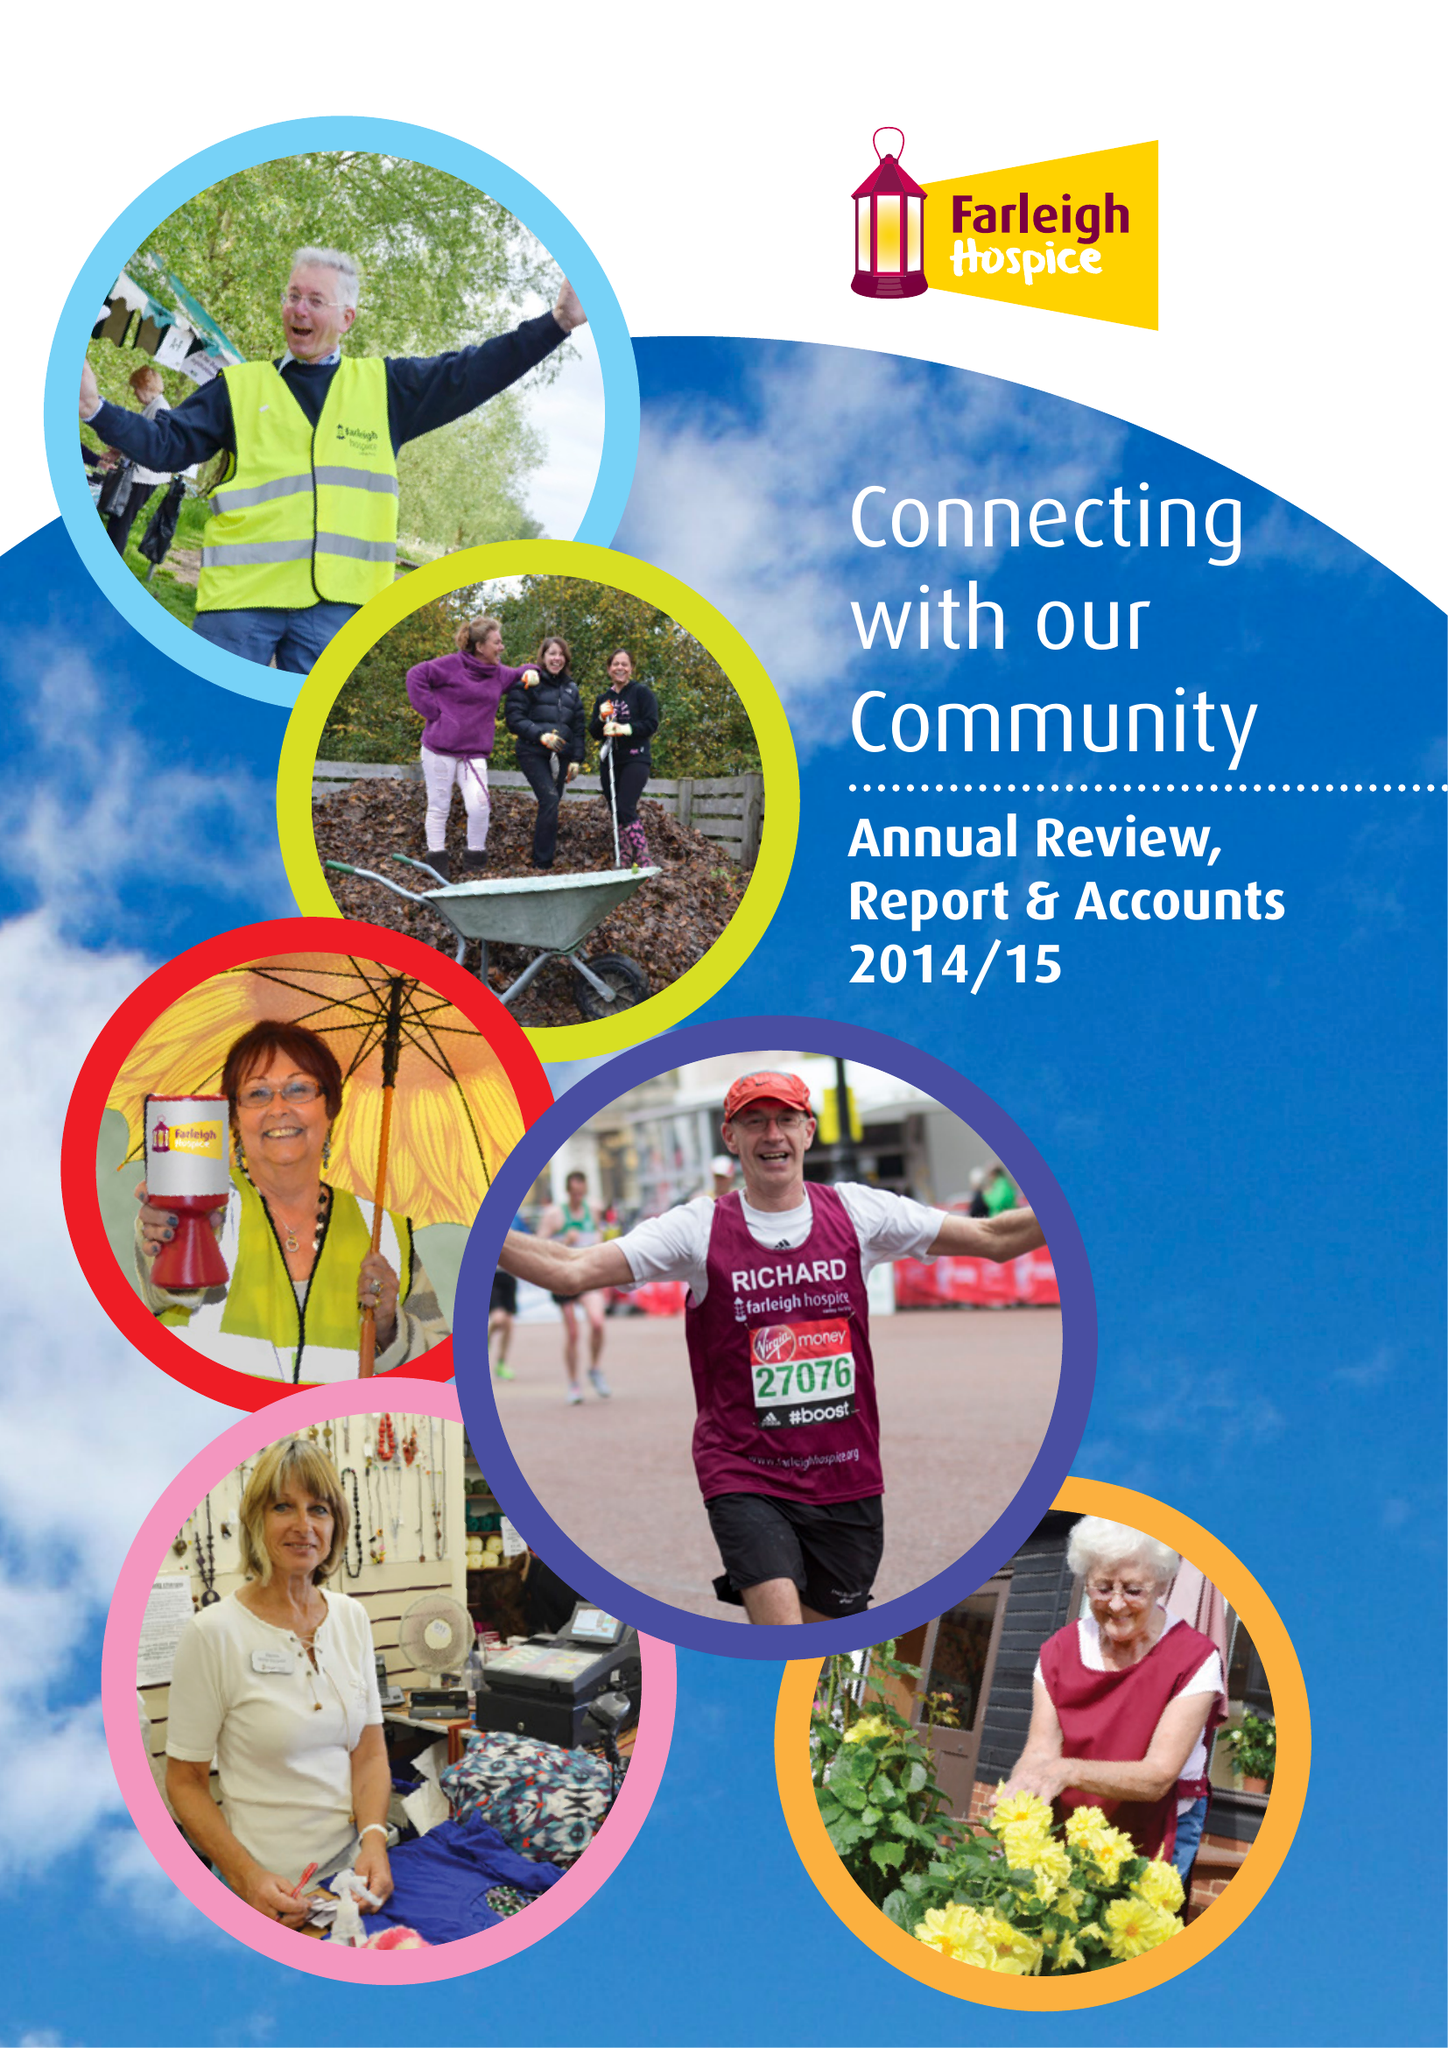What is the value for the income_annually_in_british_pounds?
Answer the question using a single word or phrase. 9120812.00 